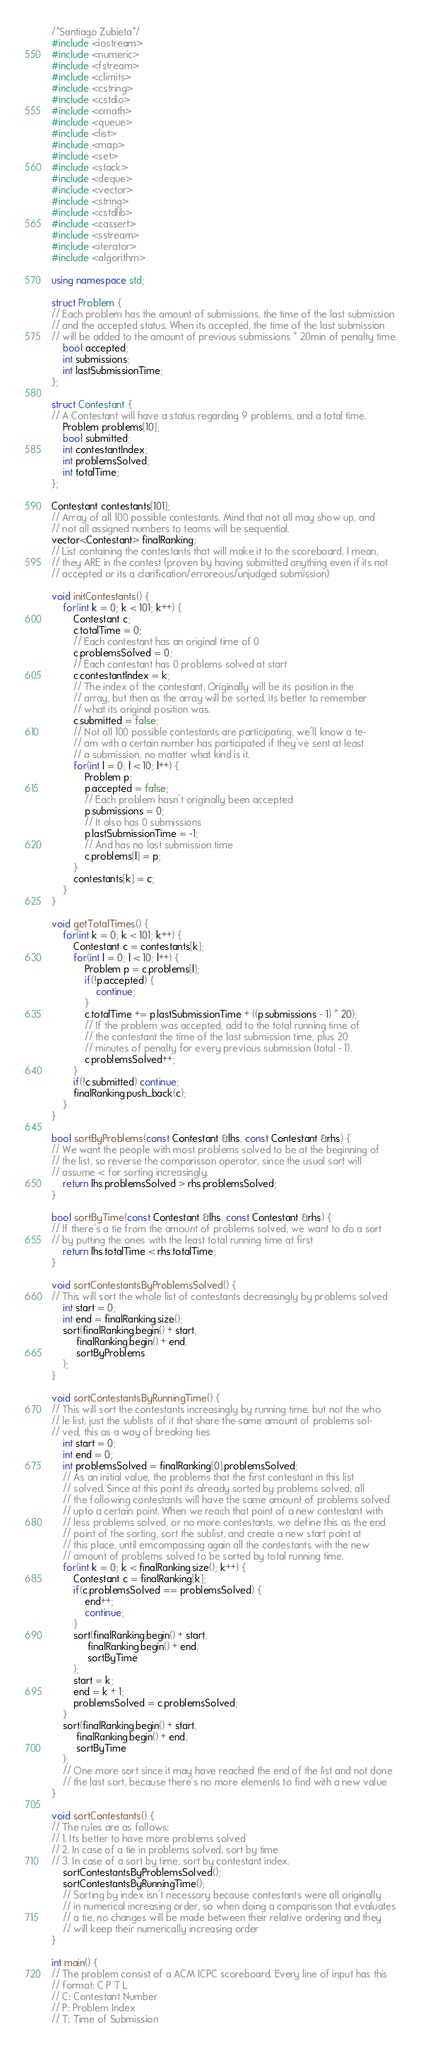Convert code to text. <code><loc_0><loc_0><loc_500><loc_500><_C++_>/*Santiago Zubieta*/
#include <iostream>
#include <numeric>
#include <fstream>
#include <climits>
#include <cstring>
#include <cstdio>
#include <cmath>
#include <queue>
#include <list>
#include <map>
#include <set>
#include <stack>
#include <deque>
#include <vector>
#include <string>
#include <cstdlib>
#include <cassert>
#include <sstream>
#include <iterator>
#include <algorithm>

using namespace std;

struct Problem {
// Each problem has the amount of submissions, the time of the last submission
// and the accepted status. When its accepted, the time of the last submission
// will be added to the amount of previous submissions * 20min of penalty time.
    bool accepted;
    int submissions;
    int lastSubmissionTime;
};

struct Contestant {
// A Contestant will have a status regarding 9 problems, and a total time.
    Problem problems[10];
    bool submitted;
    int contestantIndex;
    int problemsSolved;
    int totalTime;
};

Contestant contestants[101];
// Array of all 100 possible contestants. Mind that not all may show up, and
// not all assigned numbers to teams will be sequential.
vector<Contestant> finalRanking;
// List containing the contestants that will make it to the scoreboard, I mean,
// they ARE in the contest (proven by having submitted anything even if its not
// accepted or its a clarification/erroreous/unjudged submission)

void initContestants() {
    for(int k = 0; k < 101; k++) {
        Contestant c;
        c.totalTime = 0;
        // Each contestant has an original time of 0
        c.problemsSolved = 0;
        // Each contestant has 0 problems solved at start
        c.contestantIndex = k;
        // The index of the contestant. Originally will be its position in the
        // array, but then as the array will be sorted, its better to remember
        // what its original position was.
        c.submitted = false;
        // Not all 100 possible contestants are participating, we'll know a te-
        // am with a certain number has participated if they've sent at least
        // a submission, no matter what kind is it.
        for(int l = 0; l < 10; l++) {
            Problem p;
            p.accepted = false;
            // Each problem hasn't originally been accepted
            p.submissions = 0;
            // It also has 0 submissions
            p.lastSubmissionTime = -1;
            // And has no last submission time
            c.problems[l] = p;
        }
        contestants[k] = c;
    }
}

void getTotalTimes() {
    for(int k = 0; k < 101; k++) {
        Contestant c = contestants[k];
        for(int l = 0; l < 10; l++) {
            Problem p = c.problems[l];
            if(!p.accepted) {
                continue;
            }
            c.totalTime += p.lastSubmissionTime + ((p.submissions - 1) * 20);
            // If the problem was accepted, add to the total running time of
            // the contestant the time of the last submission time, plus 20
            // minutes of penalty for every previous submission (total - 1).
            c.problemsSolved++;
        }
        if(!c.submitted) continue;
        finalRanking.push_back(c);
    }
}

bool sortByProblems(const Contestant &lhs, const Contestant &rhs) {
// We want the people with most problems solved to be at the beginning of
// the list, so reverse the comparisson operator, since the usual sort will
// assume < for sorting increasingly.
    return lhs.problemsSolved > rhs.problemsSolved;
}

bool sortByTime(const Contestant &lhs, const Contestant &rhs) {
// If there's a tie from the amount of problems solved, we want to do a sort
// by putting the ones with the least total running time at first
    return lhs.totalTime < rhs.totalTime;
}

void sortContestantsByProblemsSolved() {
// This will sort the whole list of contestants decreasingly by problems solved
    int start = 0;
    int end = finalRanking.size();
    sort(finalRanking.begin() + start, 
         finalRanking.begin() + end, 
         sortByProblems
    );
}

void sortContestantsByRunningTime() {
// This will sort the contestants increasingly by running time, but not the who
// le list, just the sublists of it that share the same amount of problems sol-
// ved, this as a way of breaking ties
    int start = 0;
    int end = 0;
    int problemsSolved = finalRanking[0].problemsSolved;
    // As an initial value, the problems that the first contestant in this list
    // solved. Since at this point its already sorted by problems solved, all
    // the following contestants will have the same amount of problems solved
    // upto a certain point. When we reach that point of a new contestant with
    // less problems solved, or no more contestants, we define this as the end
    // point of the sorting, sort the sublist, and create a new start point at
    // this place, until emcompassing again all the contestants with the new
    // amount of problems solved to be sorted by total running time.
    for(int k = 0; k < finalRanking.size(); k++) {
        Contestant c = finalRanking[k];
        if(c.problemsSolved == problemsSolved) {
            end++;
            continue;
        }
        sort(finalRanking.begin() + start,
             finalRanking.begin() + end,
             sortByTime
        );
        start = k;
        end = k + 1;
        problemsSolved = c.problemsSolved;
    }
    sort(finalRanking.begin() + start,
         finalRanking.begin() + end,
         sortByTime
    );
    // One more sort since it may have reached the end of the list and not done
    // the last sort, because there's no more elements to find with a new value
}

void sortContestants() {
// The rules are as follows:
// 1. Its better to have more problems solved
// 2. In case of a tie in problems solved, sort by time
// 3. In case of a sort by time, sort by contestant index.
    sortContestantsByProblemsSolved();
    sortContestantsByRunningTime();
    // Sorting by index isn't necessary because contestants were all originally
    // in numerical increasing order, so when doing a comparisson that evaluates
    // a tie, no changes will be made between their relative ordering and they
    // will keep their numerically increasing order
}

int main() {
// The problem consist of a ACM ICPC scoreboard. Every line of input has this
// format: C P T L
// C: Contestant Number
// P: Problem Index
// T: Time of Submission</code> 